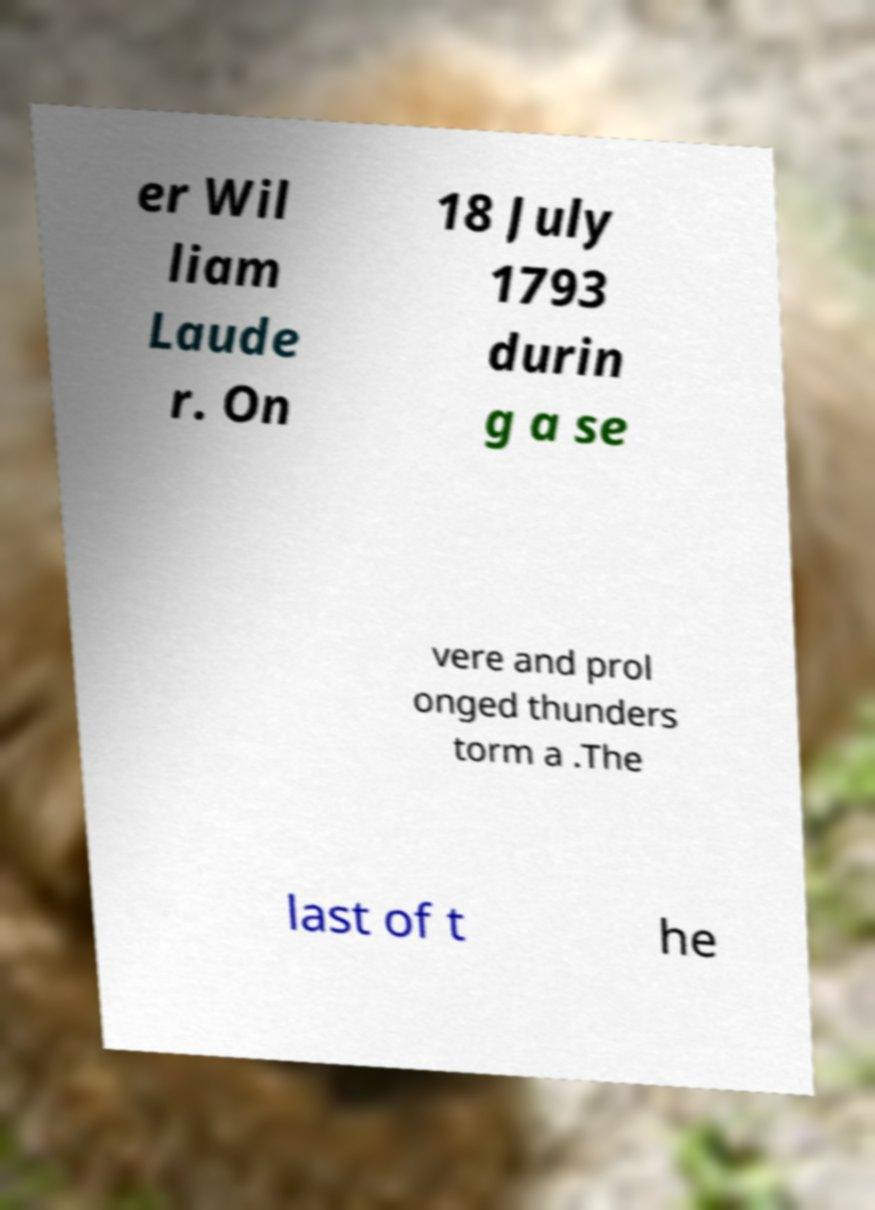For documentation purposes, I need the text within this image transcribed. Could you provide that? er Wil liam Laude r. On 18 July 1793 durin g a se vere and prol onged thunders torm a .The last of t he 